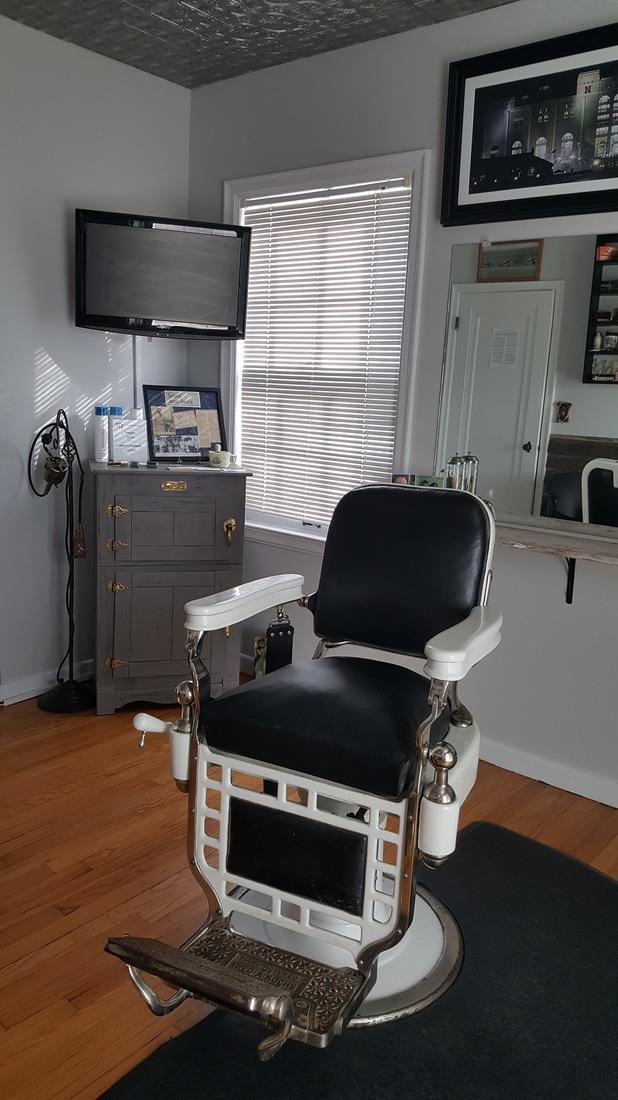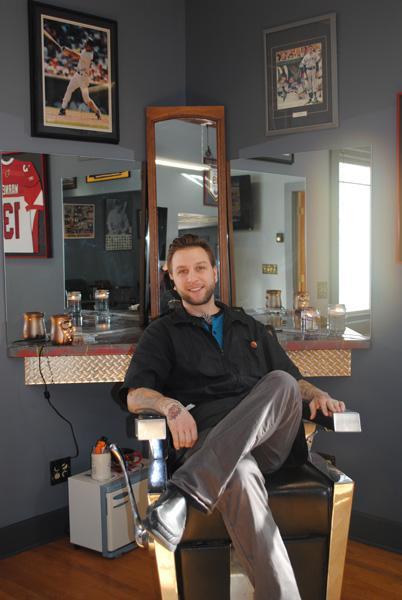The first image is the image on the left, the second image is the image on the right. For the images displayed, is the sentence "There are people in both images." factually correct? Answer yes or no. No. The first image is the image on the left, the second image is the image on the right. For the images displayed, is the sentence "There is a total of three people in the barber shop." factually correct? Answer yes or no. No. 